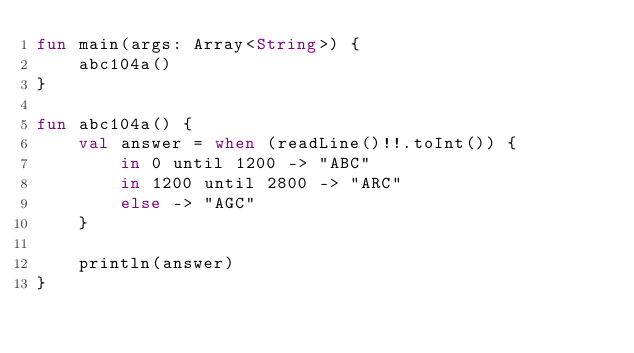<code> <loc_0><loc_0><loc_500><loc_500><_Kotlin_>fun main(args: Array<String>) {
    abc104a()
}

fun abc104a() {
    val answer = when (readLine()!!.toInt()) {
        in 0 until 1200 -> "ABC"
        in 1200 until 2800 -> "ARC"
        else -> "AGC"
    }

    println(answer)
}
</code> 